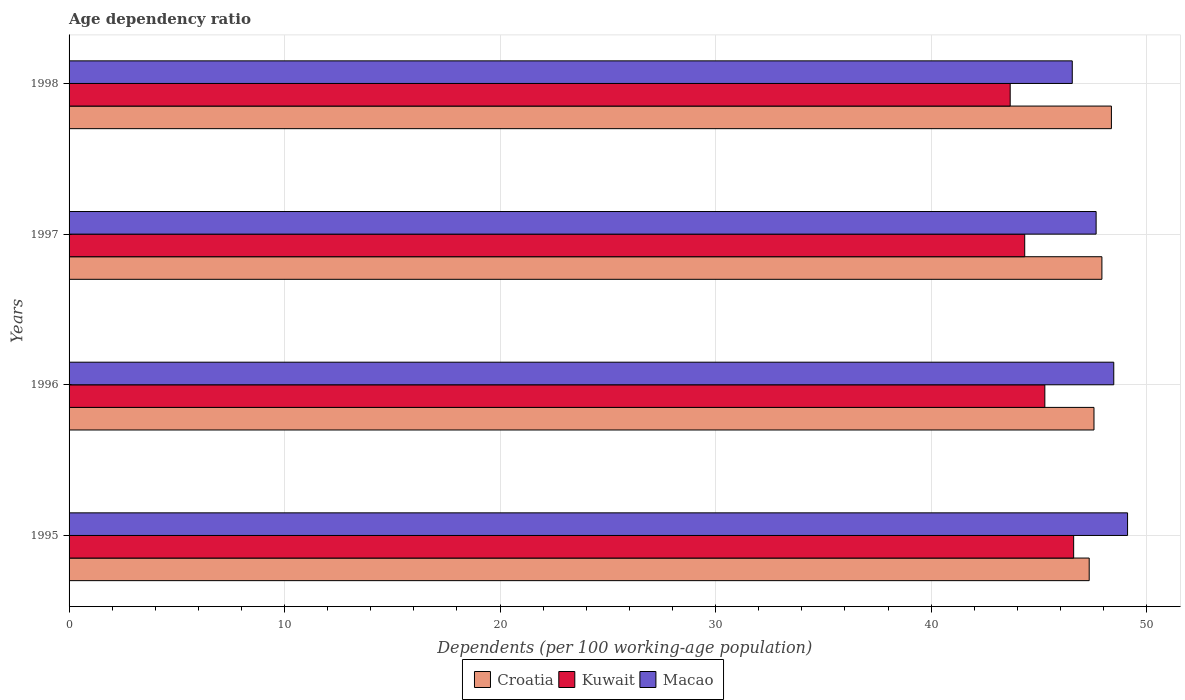How many bars are there on the 3rd tick from the top?
Provide a short and direct response. 3. What is the age dependency ratio in in Macao in 1996?
Offer a terse response. 48.48. Across all years, what is the maximum age dependency ratio in in Macao?
Your answer should be very brief. 49.12. Across all years, what is the minimum age dependency ratio in in Kuwait?
Make the answer very short. 43.67. What is the total age dependency ratio in in Croatia in the graph?
Provide a succinct answer. 191.19. What is the difference between the age dependency ratio in in Kuwait in 1995 and that in 1998?
Your answer should be very brief. 2.94. What is the difference between the age dependency ratio in in Croatia in 1998 and the age dependency ratio in in Macao in 1995?
Give a very brief answer. -0.75. What is the average age dependency ratio in in Croatia per year?
Give a very brief answer. 47.8. In the year 1996, what is the difference between the age dependency ratio in in Macao and age dependency ratio in in Kuwait?
Offer a terse response. 3.2. What is the ratio of the age dependency ratio in in Macao in 1995 to that in 1996?
Offer a very short reply. 1.01. Is the age dependency ratio in in Macao in 1997 less than that in 1998?
Your answer should be very brief. No. What is the difference between the highest and the second highest age dependency ratio in in Croatia?
Ensure brevity in your answer.  0.44. What is the difference between the highest and the lowest age dependency ratio in in Macao?
Your answer should be compact. 2.57. In how many years, is the age dependency ratio in in Croatia greater than the average age dependency ratio in in Croatia taken over all years?
Your response must be concise. 2. What does the 1st bar from the top in 1996 represents?
Your answer should be compact. Macao. What does the 1st bar from the bottom in 1997 represents?
Give a very brief answer. Croatia. How many bars are there?
Keep it short and to the point. 12. How many years are there in the graph?
Offer a terse response. 4. Are the values on the major ticks of X-axis written in scientific E-notation?
Keep it short and to the point. No. Does the graph contain any zero values?
Provide a succinct answer. No. Where does the legend appear in the graph?
Keep it short and to the point. Bottom center. How many legend labels are there?
Give a very brief answer. 3. What is the title of the graph?
Offer a terse response. Age dependency ratio. Does "El Salvador" appear as one of the legend labels in the graph?
Make the answer very short. No. What is the label or title of the X-axis?
Make the answer very short. Dependents (per 100 working-age population). What is the Dependents (per 100 working-age population) of Croatia in 1995?
Your answer should be compact. 47.34. What is the Dependents (per 100 working-age population) in Kuwait in 1995?
Give a very brief answer. 46.62. What is the Dependents (per 100 working-age population) in Macao in 1995?
Provide a short and direct response. 49.12. What is the Dependents (per 100 working-age population) in Croatia in 1996?
Your answer should be very brief. 47.56. What is the Dependents (per 100 working-age population) of Kuwait in 1996?
Keep it short and to the point. 45.28. What is the Dependents (per 100 working-age population) in Macao in 1996?
Make the answer very short. 48.48. What is the Dependents (per 100 working-age population) of Croatia in 1997?
Keep it short and to the point. 47.93. What is the Dependents (per 100 working-age population) in Kuwait in 1997?
Provide a succinct answer. 44.34. What is the Dependents (per 100 working-age population) of Macao in 1997?
Your answer should be compact. 47.66. What is the Dependents (per 100 working-age population) in Croatia in 1998?
Your response must be concise. 48.37. What is the Dependents (per 100 working-age population) in Kuwait in 1998?
Offer a very short reply. 43.67. What is the Dependents (per 100 working-age population) of Macao in 1998?
Provide a succinct answer. 46.55. Across all years, what is the maximum Dependents (per 100 working-age population) of Croatia?
Give a very brief answer. 48.37. Across all years, what is the maximum Dependents (per 100 working-age population) of Kuwait?
Provide a succinct answer. 46.62. Across all years, what is the maximum Dependents (per 100 working-age population) of Macao?
Provide a short and direct response. 49.12. Across all years, what is the minimum Dependents (per 100 working-age population) in Croatia?
Make the answer very short. 47.34. Across all years, what is the minimum Dependents (per 100 working-age population) in Kuwait?
Your answer should be compact. 43.67. Across all years, what is the minimum Dependents (per 100 working-age population) of Macao?
Your answer should be compact. 46.55. What is the total Dependents (per 100 working-age population) of Croatia in the graph?
Your response must be concise. 191.19. What is the total Dependents (per 100 working-age population) of Kuwait in the graph?
Make the answer very short. 179.91. What is the total Dependents (per 100 working-age population) in Macao in the graph?
Provide a succinct answer. 191.8. What is the difference between the Dependents (per 100 working-age population) in Croatia in 1995 and that in 1996?
Your answer should be compact. -0.22. What is the difference between the Dependents (per 100 working-age population) of Kuwait in 1995 and that in 1996?
Offer a terse response. 1.34. What is the difference between the Dependents (per 100 working-age population) of Macao in 1995 and that in 1996?
Ensure brevity in your answer.  0.64. What is the difference between the Dependents (per 100 working-age population) of Croatia in 1995 and that in 1997?
Ensure brevity in your answer.  -0.59. What is the difference between the Dependents (per 100 working-age population) of Kuwait in 1995 and that in 1997?
Your response must be concise. 2.27. What is the difference between the Dependents (per 100 working-age population) of Macao in 1995 and that in 1997?
Offer a very short reply. 1.46. What is the difference between the Dependents (per 100 working-age population) of Croatia in 1995 and that in 1998?
Offer a terse response. -1.03. What is the difference between the Dependents (per 100 working-age population) in Kuwait in 1995 and that in 1998?
Offer a very short reply. 2.94. What is the difference between the Dependents (per 100 working-age population) in Macao in 1995 and that in 1998?
Your answer should be very brief. 2.57. What is the difference between the Dependents (per 100 working-age population) in Croatia in 1996 and that in 1997?
Your response must be concise. -0.37. What is the difference between the Dependents (per 100 working-age population) of Kuwait in 1996 and that in 1997?
Your answer should be compact. 0.93. What is the difference between the Dependents (per 100 working-age population) of Macao in 1996 and that in 1997?
Offer a very short reply. 0.82. What is the difference between the Dependents (per 100 working-age population) in Croatia in 1996 and that in 1998?
Give a very brief answer. -0.81. What is the difference between the Dependents (per 100 working-age population) in Kuwait in 1996 and that in 1998?
Your response must be concise. 1.61. What is the difference between the Dependents (per 100 working-age population) of Macao in 1996 and that in 1998?
Offer a very short reply. 1.93. What is the difference between the Dependents (per 100 working-age population) of Croatia in 1997 and that in 1998?
Offer a terse response. -0.44. What is the difference between the Dependents (per 100 working-age population) in Kuwait in 1997 and that in 1998?
Your answer should be very brief. 0.67. What is the difference between the Dependents (per 100 working-age population) of Macao in 1997 and that in 1998?
Your answer should be very brief. 1.11. What is the difference between the Dependents (per 100 working-age population) of Croatia in 1995 and the Dependents (per 100 working-age population) of Kuwait in 1996?
Offer a very short reply. 2.06. What is the difference between the Dependents (per 100 working-age population) of Croatia in 1995 and the Dependents (per 100 working-age population) of Macao in 1996?
Your response must be concise. -1.14. What is the difference between the Dependents (per 100 working-age population) of Kuwait in 1995 and the Dependents (per 100 working-age population) of Macao in 1996?
Your answer should be very brief. -1.86. What is the difference between the Dependents (per 100 working-age population) in Croatia in 1995 and the Dependents (per 100 working-age population) in Kuwait in 1997?
Provide a short and direct response. 2.99. What is the difference between the Dependents (per 100 working-age population) of Croatia in 1995 and the Dependents (per 100 working-age population) of Macao in 1997?
Your response must be concise. -0.32. What is the difference between the Dependents (per 100 working-age population) in Kuwait in 1995 and the Dependents (per 100 working-age population) in Macao in 1997?
Keep it short and to the point. -1.04. What is the difference between the Dependents (per 100 working-age population) in Croatia in 1995 and the Dependents (per 100 working-age population) in Kuwait in 1998?
Your answer should be very brief. 3.67. What is the difference between the Dependents (per 100 working-age population) of Croatia in 1995 and the Dependents (per 100 working-age population) of Macao in 1998?
Provide a short and direct response. 0.79. What is the difference between the Dependents (per 100 working-age population) of Kuwait in 1995 and the Dependents (per 100 working-age population) of Macao in 1998?
Ensure brevity in your answer.  0.06. What is the difference between the Dependents (per 100 working-age population) in Croatia in 1996 and the Dependents (per 100 working-age population) in Kuwait in 1997?
Your answer should be very brief. 3.21. What is the difference between the Dependents (per 100 working-age population) of Croatia in 1996 and the Dependents (per 100 working-age population) of Macao in 1997?
Offer a very short reply. -0.1. What is the difference between the Dependents (per 100 working-age population) in Kuwait in 1996 and the Dependents (per 100 working-age population) in Macao in 1997?
Offer a very short reply. -2.38. What is the difference between the Dependents (per 100 working-age population) in Croatia in 1996 and the Dependents (per 100 working-age population) in Kuwait in 1998?
Provide a short and direct response. 3.89. What is the difference between the Dependents (per 100 working-age population) in Croatia in 1996 and the Dependents (per 100 working-age population) in Macao in 1998?
Make the answer very short. 1.01. What is the difference between the Dependents (per 100 working-age population) of Kuwait in 1996 and the Dependents (per 100 working-age population) of Macao in 1998?
Offer a very short reply. -1.27. What is the difference between the Dependents (per 100 working-age population) of Croatia in 1997 and the Dependents (per 100 working-age population) of Kuwait in 1998?
Ensure brevity in your answer.  4.26. What is the difference between the Dependents (per 100 working-age population) in Croatia in 1997 and the Dependents (per 100 working-age population) in Macao in 1998?
Your answer should be compact. 1.37. What is the difference between the Dependents (per 100 working-age population) in Kuwait in 1997 and the Dependents (per 100 working-age population) in Macao in 1998?
Your answer should be very brief. -2.21. What is the average Dependents (per 100 working-age population) of Croatia per year?
Make the answer very short. 47.8. What is the average Dependents (per 100 working-age population) of Kuwait per year?
Provide a short and direct response. 44.98. What is the average Dependents (per 100 working-age population) in Macao per year?
Make the answer very short. 47.95. In the year 1995, what is the difference between the Dependents (per 100 working-age population) in Croatia and Dependents (per 100 working-age population) in Kuwait?
Keep it short and to the point. 0.72. In the year 1995, what is the difference between the Dependents (per 100 working-age population) of Croatia and Dependents (per 100 working-age population) of Macao?
Provide a succinct answer. -1.78. In the year 1995, what is the difference between the Dependents (per 100 working-age population) in Kuwait and Dependents (per 100 working-age population) in Macao?
Make the answer very short. -2.5. In the year 1996, what is the difference between the Dependents (per 100 working-age population) in Croatia and Dependents (per 100 working-age population) in Kuwait?
Offer a terse response. 2.28. In the year 1996, what is the difference between the Dependents (per 100 working-age population) of Croatia and Dependents (per 100 working-age population) of Macao?
Your answer should be compact. -0.92. In the year 1996, what is the difference between the Dependents (per 100 working-age population) in Kuwait and Dependents (per 100 working-age population) in Macao?
Provide a short and direct response. -3.2. In the year 1997, what is the difference between the Dependents (per 100 working-age population) of Croatia and Dependents (per 100 working-age population) of Kuwait?
Your answer should be very brief. 3.58. In the year 1997, what is the difference between the Dependents (per 100 working-age population) in Croatia and Dependents (per 100 working-age population) in Macao?
Your answer should be compact. 0.27. In the year 1997, what is the difference between the Dependents (per 100 working-age population) of Kuwait and Dependents (per 100 working-age population) of Macao?
Ensure brevity in your answer.  -3.31. In the year 1998, what is the difference between the Dependents (per 100 working-age population) of Croatia and Dependents (per 100 working-age population) of Kuwait?
Your answer should be compact. 4.7. In the year 1998, what is the difference between the Dependents (per 100 working-age population) of Croatia and Dependents (per 100 working-age population) of Macao?
Offer a very short reply. 1.82. In the year 1998, what is the difference between the Dependents (per 100 working-age population) of Kuwait and Dependents (per 100 working-age population) of Macao?
Your answer should be very brief. -2.88. What is the ratio of the Dependents (per 100 working-age population) in Croatia in 1995 to that in 1996?
Your response must be concise. 1. What is the ratio of the Dependents (per 100 working-age population) of Kuwait in 1995 to that in 1996?
Provide a succinct answer. 1.03. What is the ratio of the Dependents (per 100 working-age population) in Macao in 1995 to that in 1996?
Give a very brief answer. 1.01. What is the ratio of the Dependents (per 100 working-age population) in Kuwait in 1995 to that in 1997?
Your response must be concise. 1.05. What is the ratio of the Dependents (per 100 working-age population) in Macao in 1995 to that in 1997?
Your answer should be compact. 1.03. What is the ratio of the Dependents (per 100 working-age population) of Croatia in 1995 to that in 1998?
Provide a succinct answer. 0.98. What is the ratio of the Dependents (per 100 working-age population) of Kuwait in 1995 to that in 1998?
Give a very brief answer. 1.07. What is the ratio of the Dependents (per 100 working-age population) of Macao in 1995 to that in 1998?
Provide a short and direct response. 1.06. What is the ratio of the Dependents (per 100 working-age population) in Macao in 1996 to that in 1997?
Provide a short and direct response. 1.02. What is the ratio of the Dependents (per 100 working-age population) of Croatia in 1996 to that in 1998?
Your answer should be compact. 0.98. What is the ratio of the Dependents (per 100 working-age population) of Kuwait in 1996 to that in 1998?
Provide a short and direct response. 1.04. What is the ratio of the Dependents (per 100 working-age population) of Macao in 1996 to that in 1998?
Make the answer very short. 1.04. What is the ratio of the Dependents (per 100 working-age population) of Croatia in 1997 to that in 1998?
Give a very brief answer. 0.99. What is the ratio of the Dependents (per 100 working-age population) of Kuwait in 1997 to that in 1998?
Keep it short and to the point. 1.02. What is the ratio of the Dependents (per 100 working-age population) in Macao in 1997 to that in 1998?
Offer a terse response. 1.02. What is the difference between the highest and the second highest Dependents (per 100 working-age population) of Croatia?
Offer a very short reply. 0.44. What is the difference between the highest and the second highest Dependents (per 100 working-age population) in Kuwait?
Provide a short and direct response. 1.34. What is the difference between the highest and the second highest Dependents (per 100 working-age population) of Macao?
Provide a succinct answer. 0.64. What is the difference between the highest and the lowest Dependents (per 100 working-age population) of Croatia?
Make the answer very short. 1.03. What is the difference between the highest and the lowest Dependents (per 100 working-age population) in Kuwait?
Ensure brevity in your answer.  2.94. What is the difference between the highest and the lowest Dependents (per 100 working-age population) of Macao?
Provide a short and direct response. 2.57. 